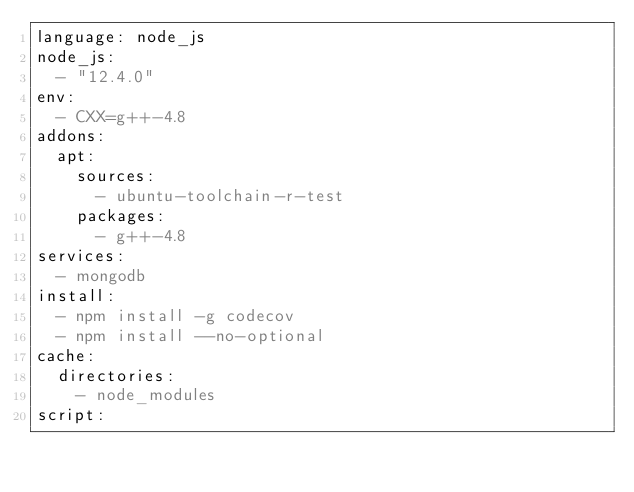Convert code to text. <code><loc_0><loc_0><loc_500><loc_500><_YAML_>language: node_js
node_js:
  - "12.4.0"
env:
  - CXX=g++-4.8
addons:
  apt:
    sources:
      - ubuntu-toolchain-r-test
    packages:
      - g++-4.8
services:
  - mongodb
install:
  - npm install -g codecov
  - npm install --no-optional
cache:
  directories:
    - node_modules
script:</code> 